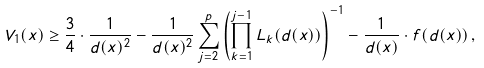Convert formula to latex. <formula><loc_0><loc_0><loc_500><loc_500>V _ { 1 } ( x ) \geq \frac { 3 } { 4 } \cdot \frac { 1 } { d ( x ) ^ { 2 } } - \frac { 1 } { d ( x ) ^ { 2 } } \sum _ { j = 2 } ^ { p } \left ( \prod _ { k = 1 } ^ { j - 1 } L _ { k } ( d ( x ) ) \right ) ^ { - 1 } - \frac { 1 } { d ( x ) } \cdot f ( d ( x ) ) \, ,</formula> 